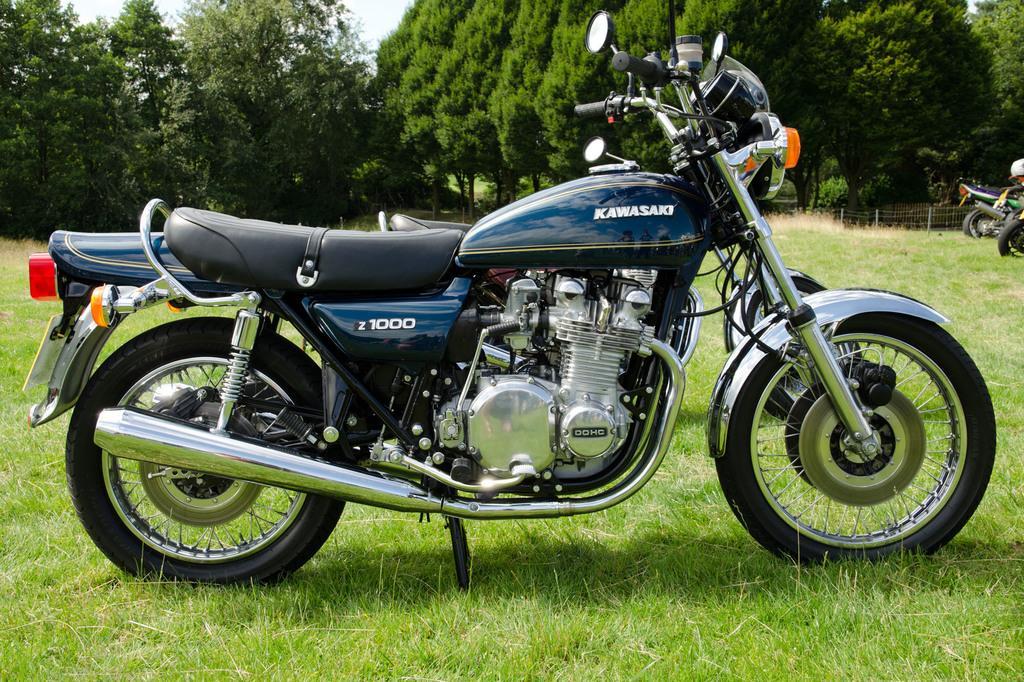Can you describe this image briefly? In this image we can see a bike parked on the grass. In the background, we can see a few more bikes, fence and trees. 